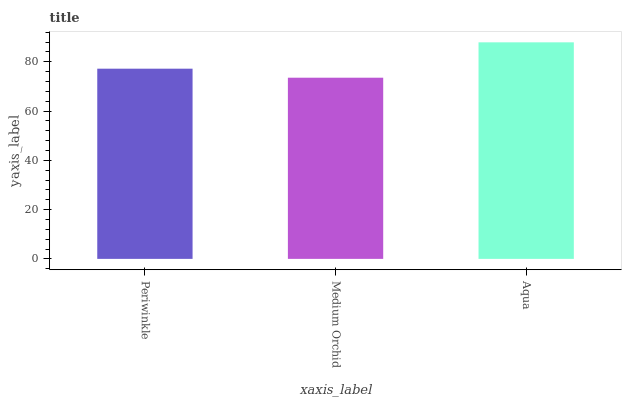Is Aqua the minimum?
Answer yes or no. No. Is Medium Orchid the maximum?
Answer yes or no. No. Is Aqua greater than Medium Orchid?
Answer yes or no. Yes. Is Medium Orchid less than Aqua?
Answer yes or no. Yes. Is Medium Orchid greater than Aqua?
Answer yes or no. No. Is Aqua less than Medium Orchid?
Answer yes or no. No. Is Periwinkle the high median?
Answer yes or no. Yes. Is Periwinkle the low median?
Answer yes or no. Yes. Is Medium Orchid the high median?
Answer yes or no. No. Is Aqua the low median?
Answer yes or no. No. 